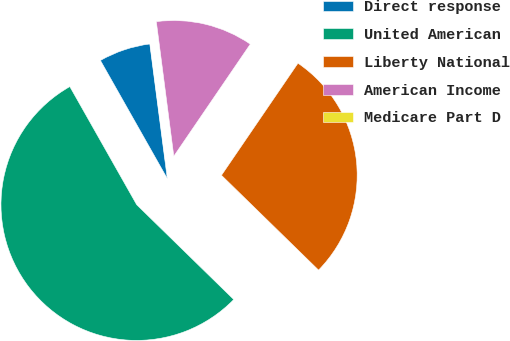Convert chart to OTSL. <chart><loc_0><loc_0><loc_500><loc_500><pie_chart><fcel>Direct response<fcel>United American<fcel>Liberty National<fcel>American Income<fcel>Medicare Part D<nl><fcel>6.14%<fcel>54.49%<fcel>27.78%<fcel>11.59%<fcel>0.0%<nl></chart> 